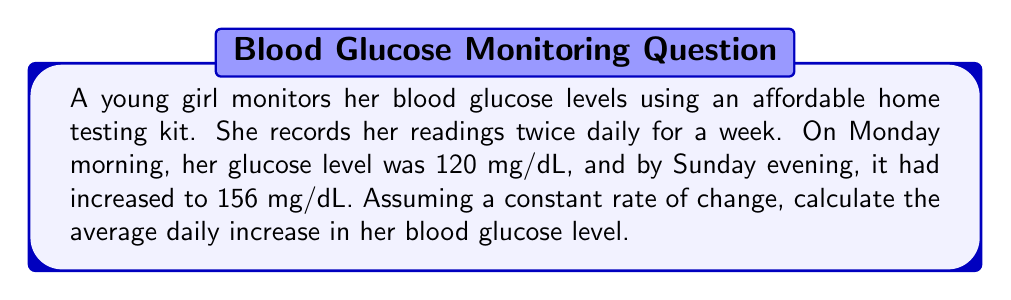Help me with this question. To solve this problem, we need to use the rate of change formula:

Rate of change = $\frac{\text{Change in y}}{\text{Change in x}}$

Let's break it down step-by-step:

1. Identify the given information:
   - Initial glucose level (Monday morning): 120 mg/dL
   - Final glucose level (Sunday evening): 156 mg/dL
   - Time period: 7 days

2. Calculate the total change in glucose level:
   $\Delta y = 156 \text{ mg/dL} - 120 \text{ mg/dL} = 36 \text{ mg/dL}$

3. Determine the change in time:
   $\Delta x = 7 \text{ days}$

4. Apply the rate of change formula:
   $$\text{Rate of change} = \frac{\Delta y}{\Delta x} = \frac{36 \text{ mg/dL}}{7 \text{ days}}$$

5. Simplify the fraction:
   $$\text{Rate of change} = \frac{36}{7} \text{ mg/dL/day} \approx 5.14 \text{ mg/dL/day}$$

Therefore, the average daily increase in her blood glucose level is approximately 5.14 mg/dL per day.
Answer: $5.14 \text{ mg/dL/day}$ 